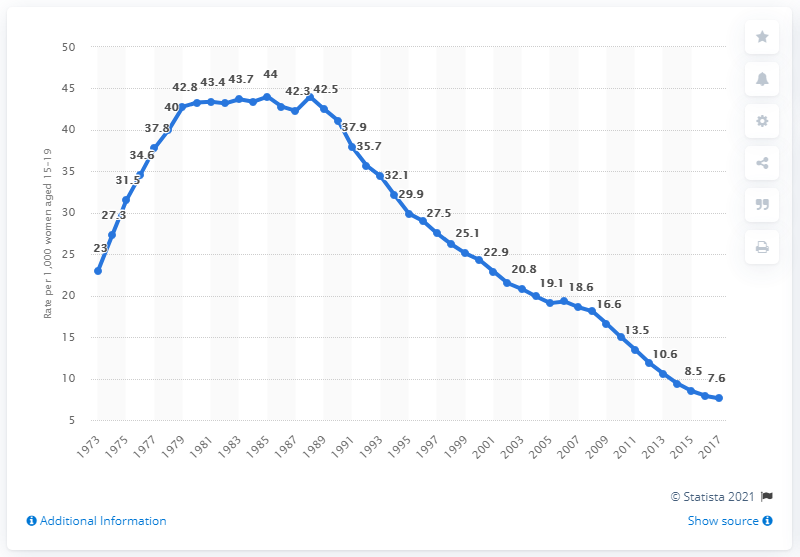Identify some key points in this picture. In the year 2017, the abortion rate per 1,000 U.S. females aged 15 to 19 was 7.6. 